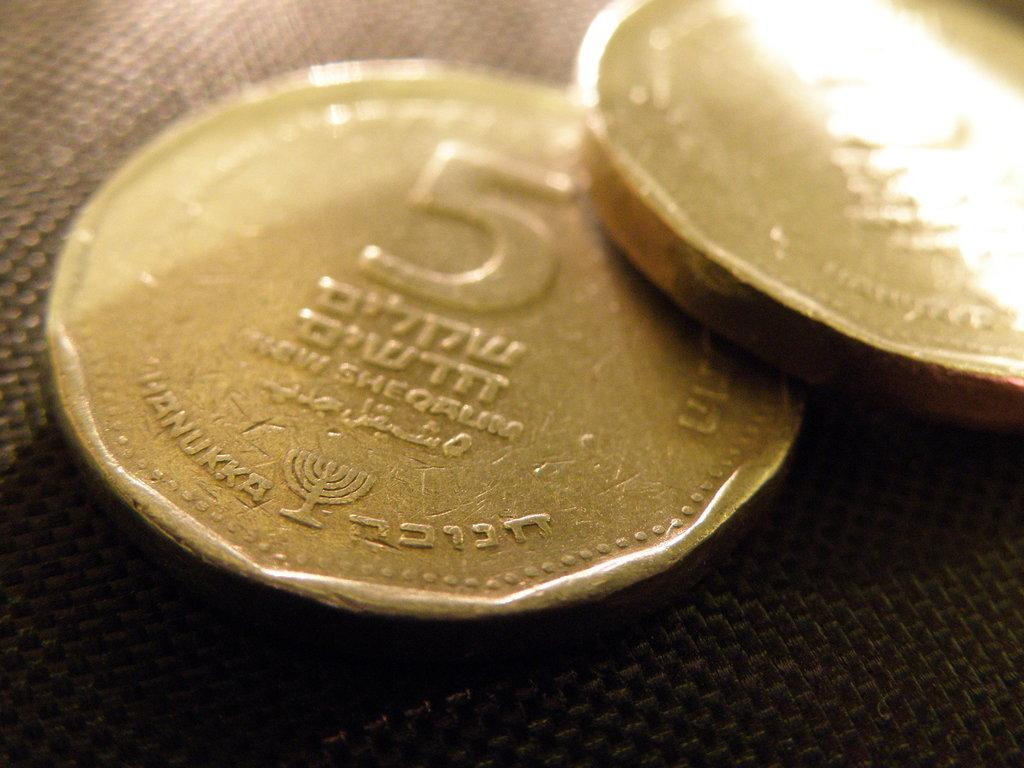How many coins are visible in the image? There are two coins in the image. What is the value of one of the coins? One of the coins has a value of five. What type of bun is being used to measure the coins in the image? There is no bun present in the image, and the coins are not being measured. 